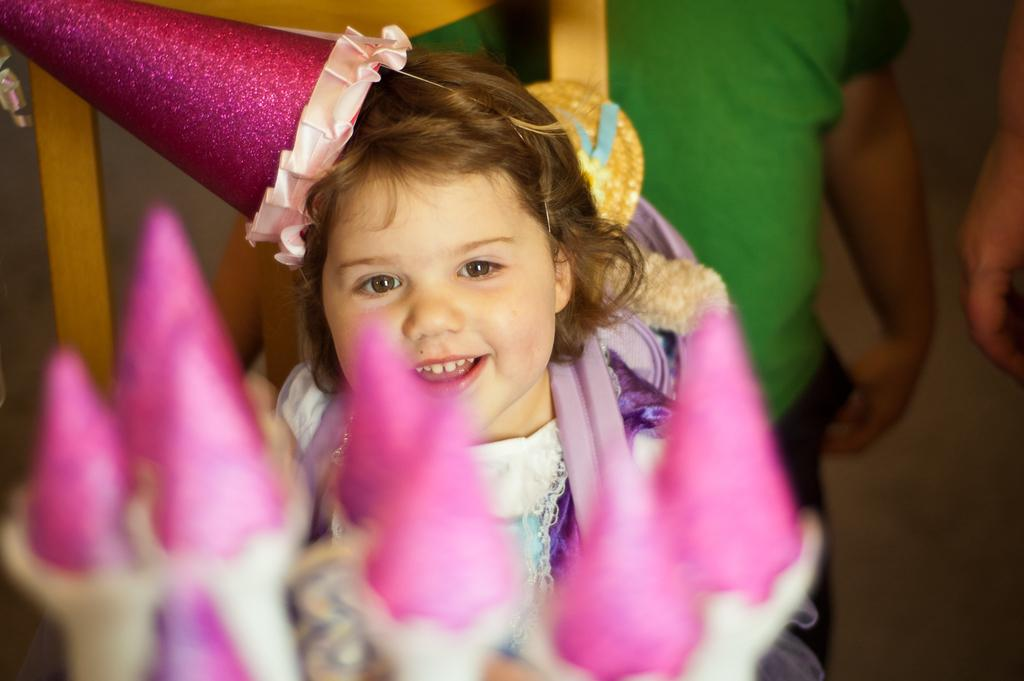What is the main subject of the image? There is a kid in the center of the image. What is the kid doing in the image? The kid is sitting on a chair. What is the kid wearing on their head? The kid is wearing a cap. What item does the kid have with them? The kid has a bag. What can be seen in the background of the image? There are people and candies visible in the background. What type of debt does the kid have in the image? There is no mention of debt in the image, and therefore no such information can be determined. What degree does the animal in the image have? There is no animal present in the image, and therefore no degree can be attributed to any animal. 